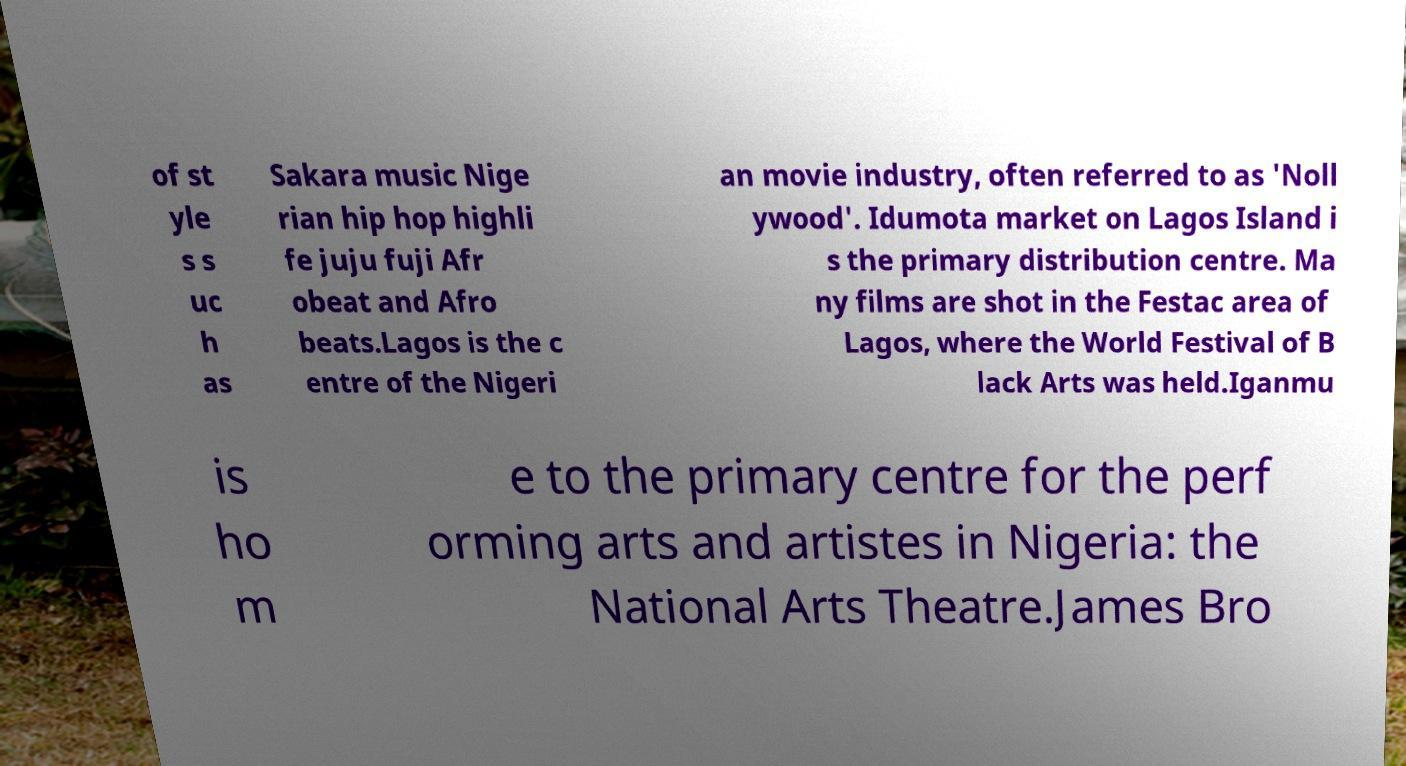Can you read and provide the text displayed in the image?This photo seems to have some interesting text. Can you extract and type it out for me? of st yle s s uc h as Sakara music Nige rian hip hop highli fe juju fuji Afr obeat and Afro beats.Lagos is the c entre of the Nigeri an movie industry, often referred to as 'Noll ywood'. Idumota market on Lagos Island i s the primary distribution centre. Ma ny films are shot in the Festac area of Lagos, where the World Festival of B lack Arts was held.Iganmu is ho m e to the primary centre for the perf orming arts and artistes in Nigeria: the National Arts Theatre.James Bro 